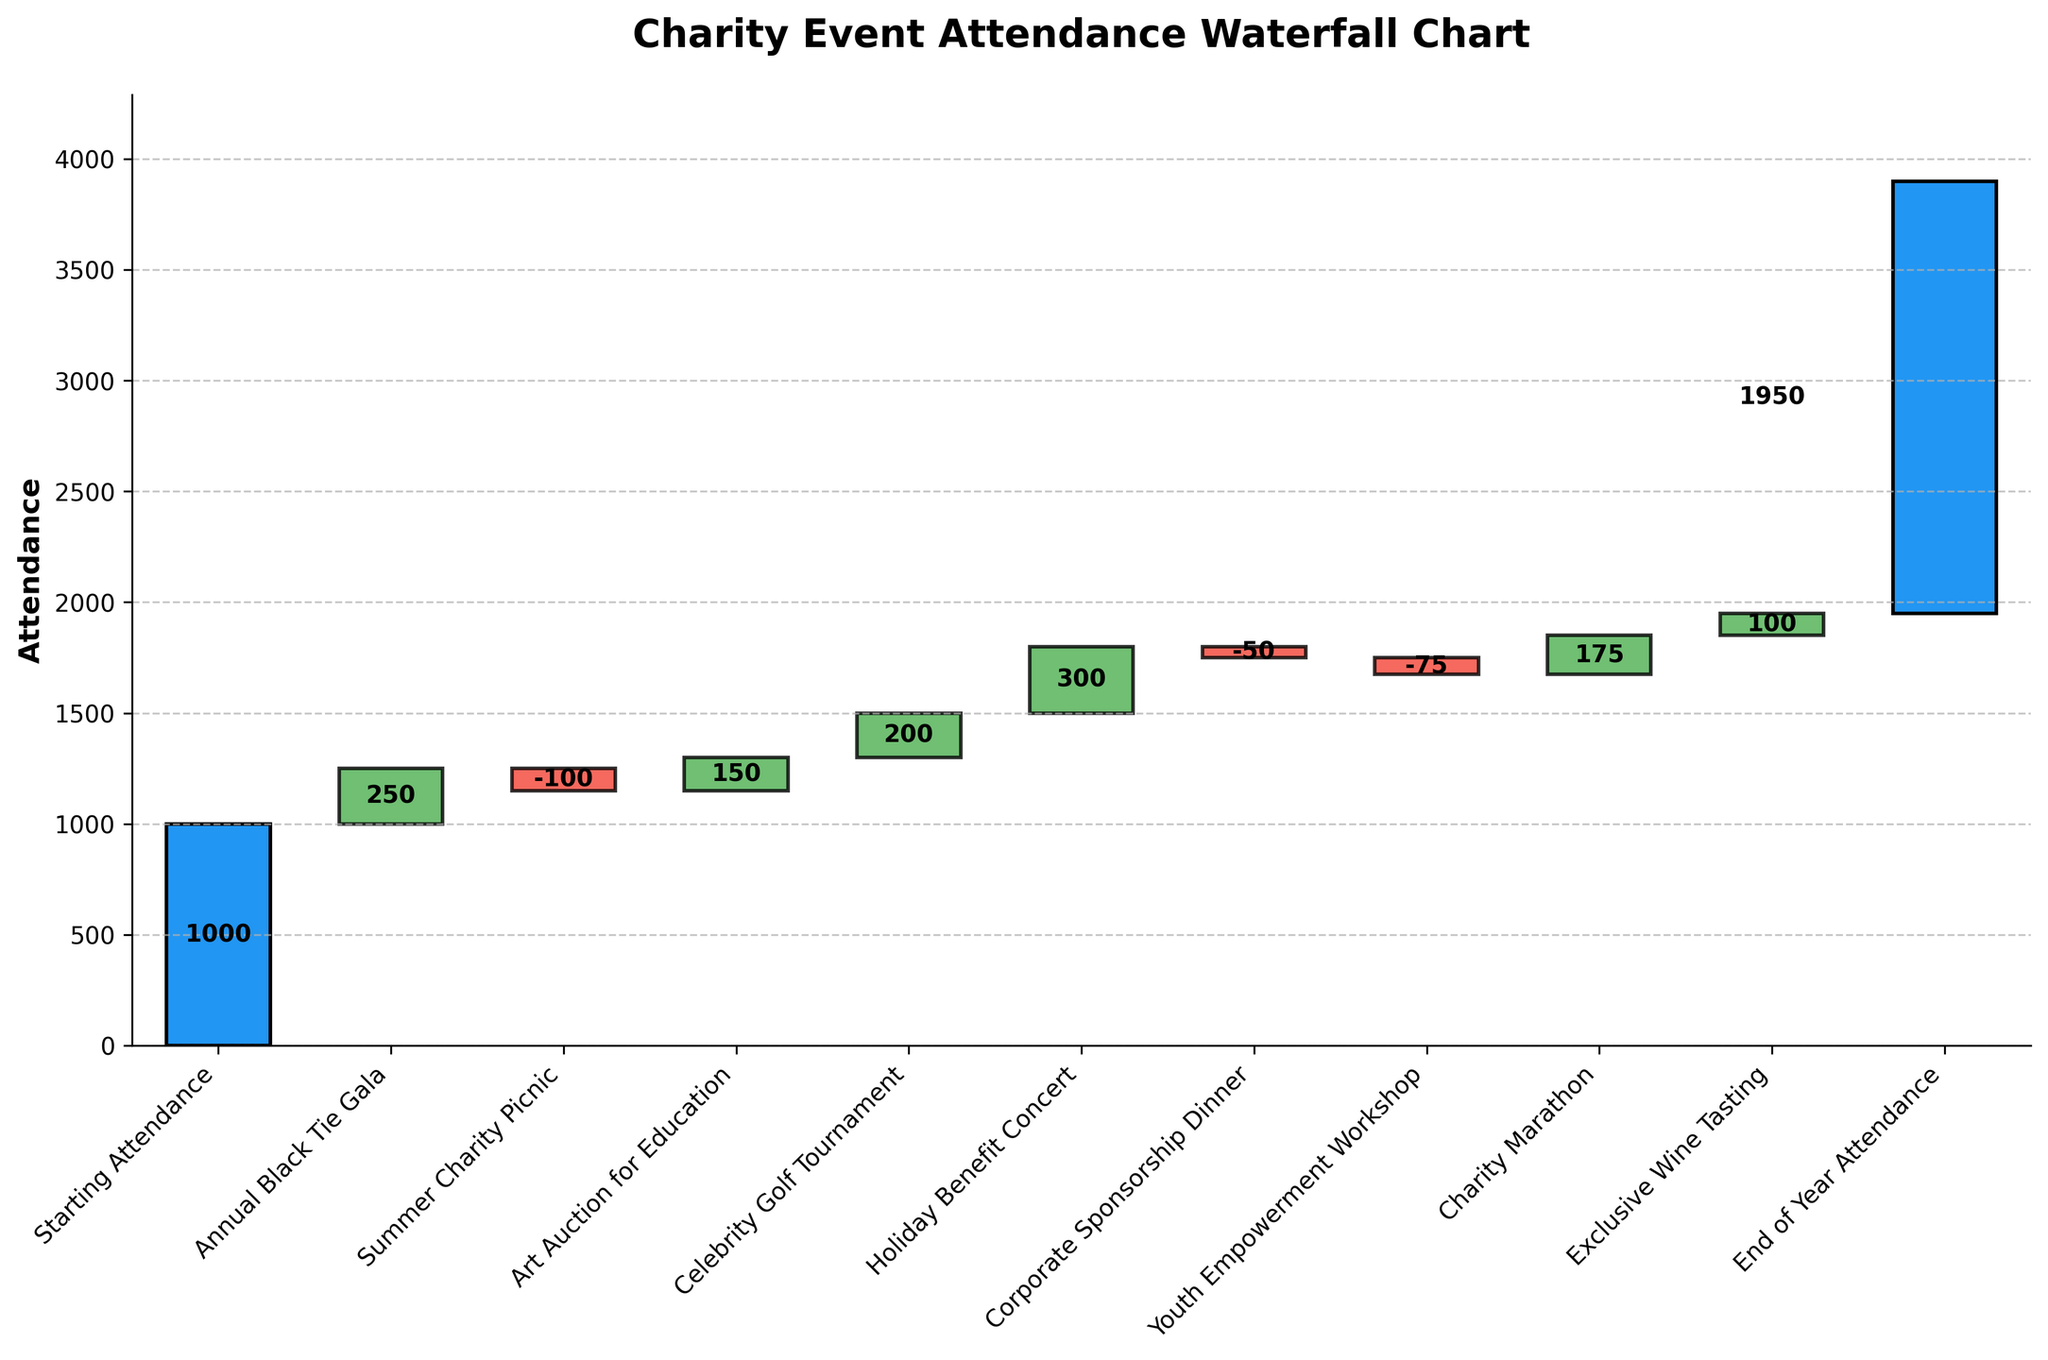How many total events are shown in the chart? We count the number of events listed on the x-axis, including the starting and ending points. There are 11 events in total starting from "Starting Attendance" to "End of Year Attendance".
Answer: 11 What is the overall change in attendance from start to end? The starting attendance is 1000 and the end-of-year attendance is 1950. The overall change is calculated by subtracting the starting number from the ending number: 1950 - 1000 = 950.
Answer: 950 How many events resulted in a decrease in attendance? To find the number of events with a decrease in attendance, we count the bars that drop downwards. Such events are the Summer Charity Picnic, Corporate Sponsorship Dinner, and Youth Empowerment Workshop, totaling 3 events.
Answer: 3 Which event had the largest increase in attendance? By examining the vertical bars, the Holiday Benefit Concert has the highest increase. From the values, it has a +300 attendance change, which is the highest among the increases.
Answer: Holiday Benefit Concert How does the attendance change at the Annual Black Tie Gala compare to the Holiday Benefit Concert? The Annual Black Tie Gala shows an increase of +250, while the Holiday Benefit Concert shows an increase of +300. Comparing the two values, the difference is 300 - 250 = 50, with the Holiday Benefit Concert having a higher increase.
Answer: +50 at Holiday Benefit Concert What is the average change in attendance across all events (excluding starting and ending points)? We sum up all individual attendance changes (250 - 100 + 150 + 200 + 300 - 50 - 75 + 175 + 100 = 950). There are 9 events, so the average is 950 / 9 = approximately 105.56.
Answer: ~105.56 Which event follows the Art Auction for Education in terms of attendance change? The event immediately following the Art Auction for Education on the x-axis is the Celebrity Golf Tournament.
Answer: Celebrity Golf Tournament What was the cumulative attendance after Corporate Sponsorship Dinner? Starting with 1000, we add the changes sequentially until the Corporate Sponsorship Dinner: 1000 + 250 - 100 + 150 + 200 + 300 - 50 = 1750.
Answer: 1750 What is the median attendance change among the events? Listing the changes: 250, -100, 150, 200, 300, -50, -75, 175, 100, and sorting them: -100, -75, -50, 100, 150, 175, 200, 250, 300. The median is the 5th value in the ordered list, which is 150.
Answer: 150 What is the cumulative effect of the negative attendance changes? The negative changes are -100, -50, and -75. Summing these values: -100 - 50 - 75 = -225.
Answer: -225 